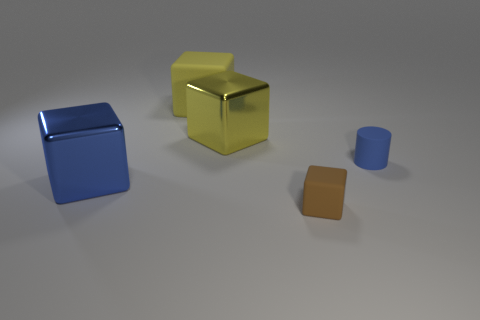What is the color of the large object behind the big yellow metal thing?
Provide a succinct answer. Yellow. Are there any other shiny things that have the same shape as the large blue thing?
Provide a succinct answer. Yes. What is the material of the tiny block?
Provide a short and direct response. Rubber. What is the size of the cube that is both in front of the tiny matte cylinder and on the right side of the blue cube?
Your answer should be very brief. Small. There is a object that is the same color as the big rubber block; what is it made of?
Offer a terse response. Metal. How many tiny cyan matte spheres are there?
Provide a succinct answer. 0. Are there fewer blue rubber things than small red metal objects?
Your response must be concise. No. What material is the other object that is the same size as the blue matte thing?
Your answer should be very brief. Rubber. What number of objects are either brown blocks or small gray cylinders?
Offer a very short reply. 1. How many cubes are both on the right side of the yellow rubber object and in front of the blue matte cylinder?
Provide a short and direct response. 1. 